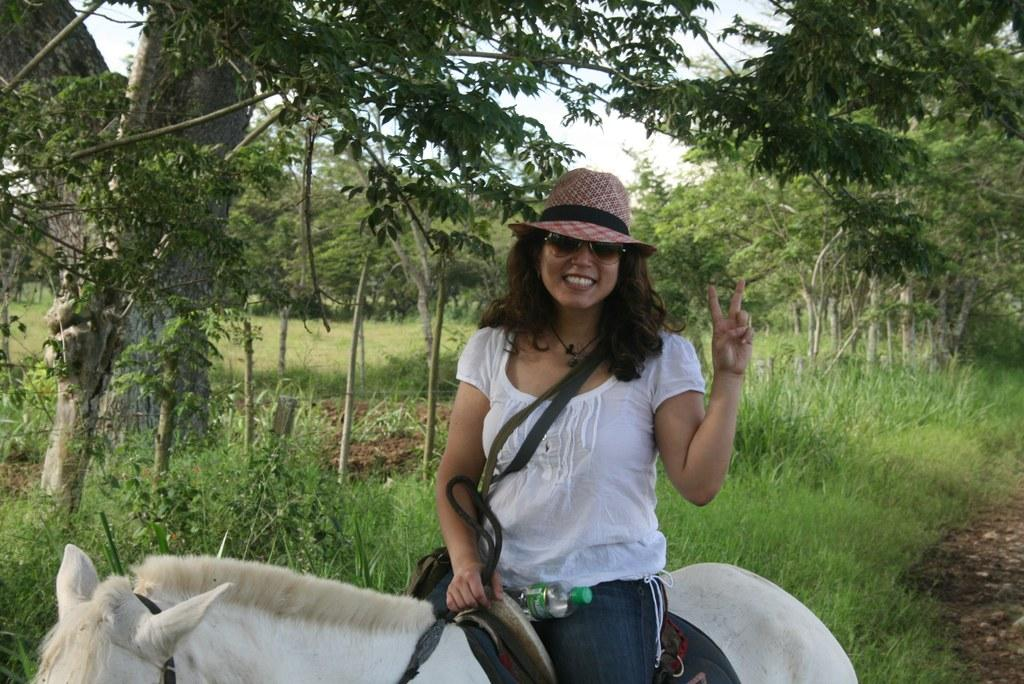What is the person in the image doing? The person is sitting on a horse. What is the person's facial expression in the image? The person is smiling. What type of headwear is the person wearing? The person is wearing a hat. What can be seen in the background of the image? There are trees, the sky, and grass visible in the background of the image. What type of mint is growing in the image? There is no mint present in the image; it features a person sitting on a horse with trees, the sky, and grass in the background. 